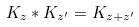<formula> <loc_0><loc_0><loc_500><loc_500>K _ { z } * K _ { z ^ { \prime } } = K _ { z + z ^ { \prime } }</formula> 